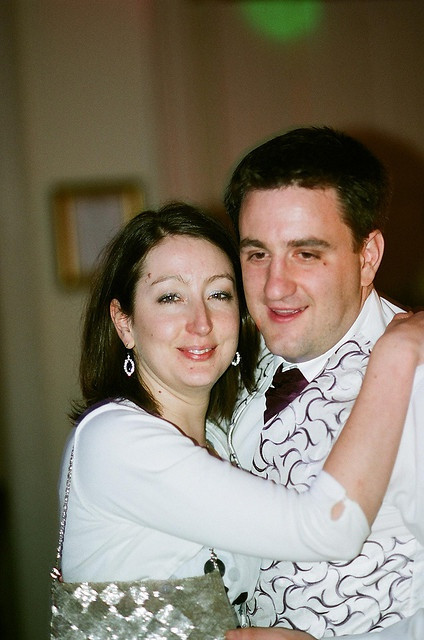Describe the objects in this image and their specific colors. I can see people in black, lightgray, tan, and darkgray tones, people in black, lightgray, tan, and darkgray tones, handbag in black, gray, darkgray, and lightgray tones, and tie in black, lightgray, and purple tones in this image. 